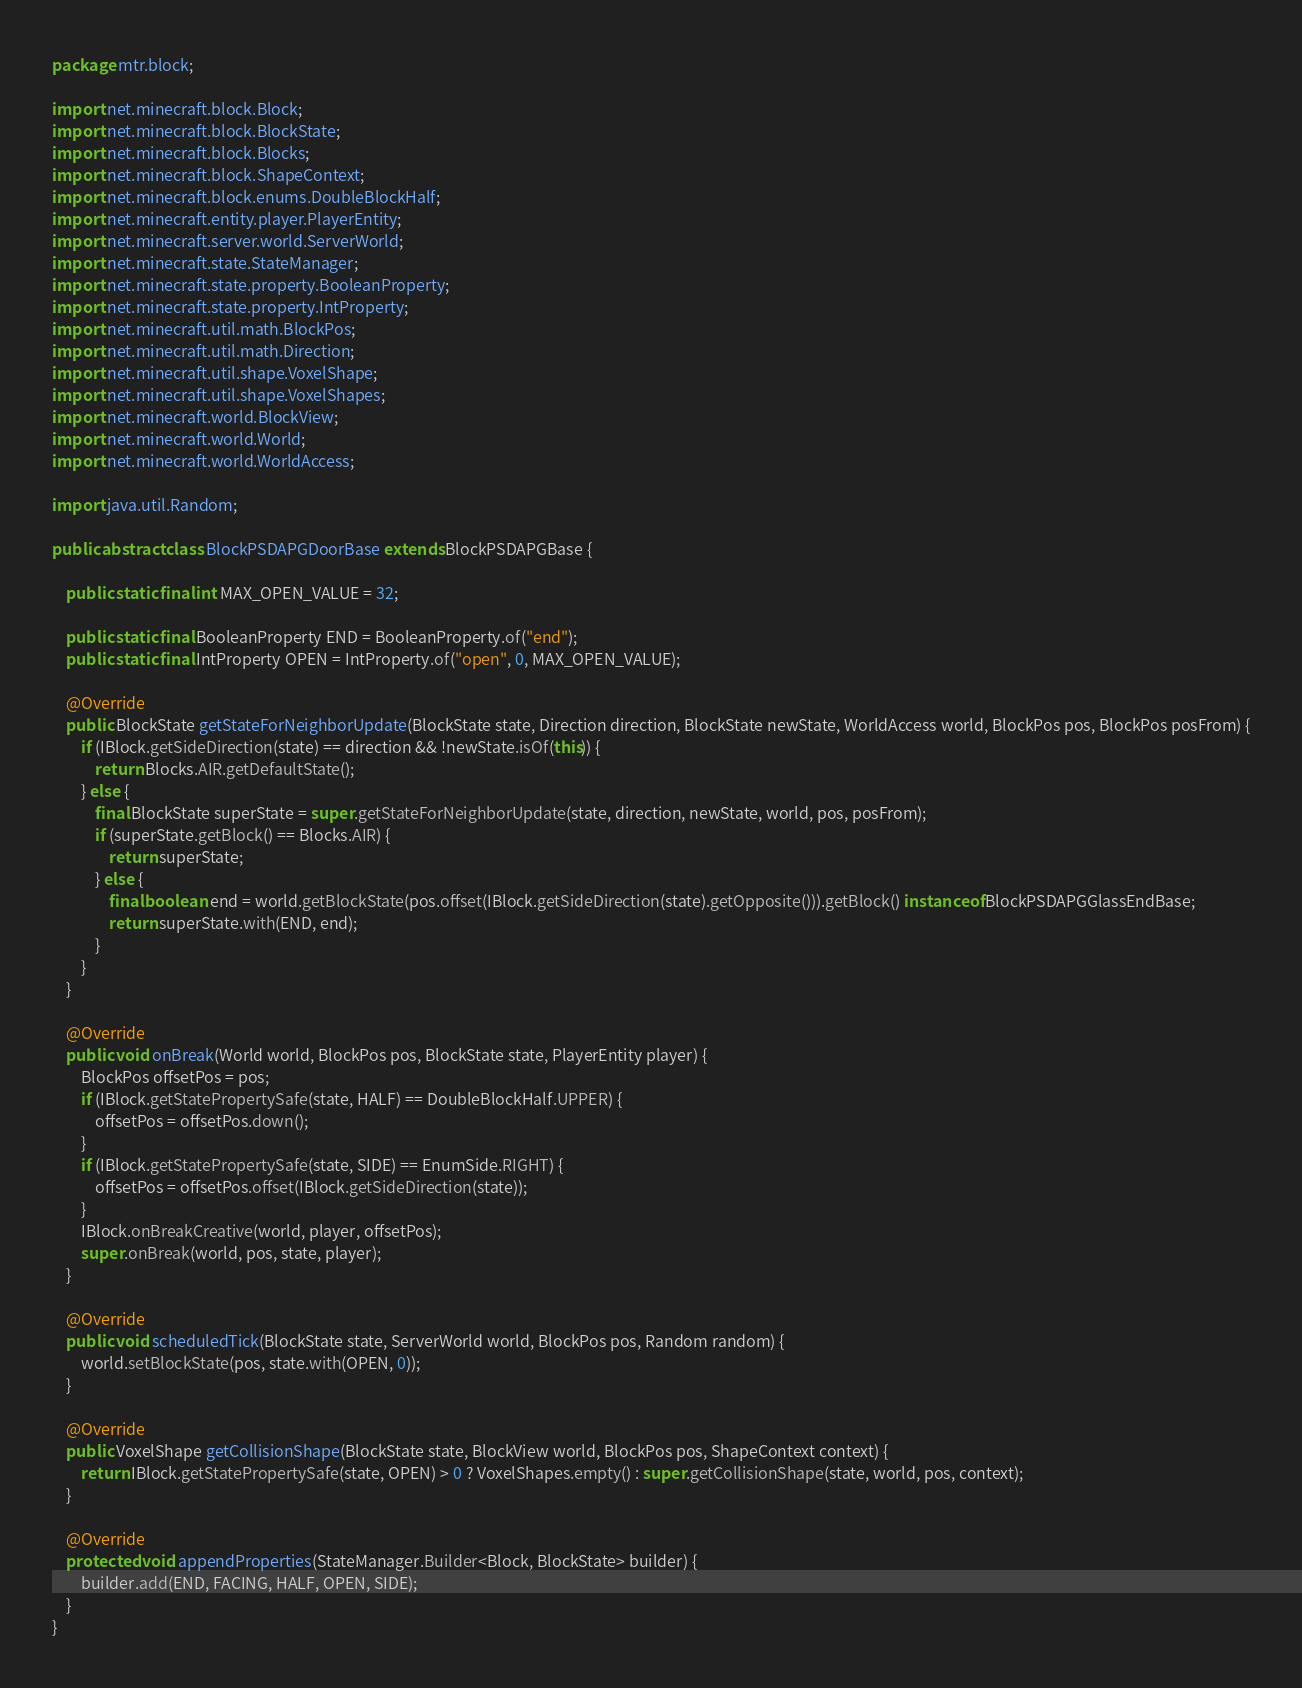<code> <loc_0><loc_0><loc_500><loc_500><_Java_>package mtr.block;

import net.minecraft.block.Block;
import net.minecraft.block.BlockState;
import net.minecraft.block.Blocks;
import net.minecraft.block.ShapeContext;
import net.minecraft.block.enums.DoubleBlockHalf;
import net.minecraft.entity.player.PlayerEntity;
import net.minecraft.server.world.ServerWorld;
import net.minecraft.state.StateManager;
import net.minecraft.state.property.BooleanProperty;
import net.minecraft.state.property.IntProperty;
import net.minecraft.util.math.BlockPos;
import net.minecraft.util.math.Direction;
import net.minecraft.util.shape.VoxelShape;
import net.minecraft.util.shape.VoxelShapes;
import net.minecraft.world.BlockView;
import net.minecraft.world.World;
import net.minecraft.world.WorldAccess;

import java.util.Random;

public abstract class BlockPSDAPGDoorBase extends BlockPSDAPGBase {

	public static final int MAX_OPEN_VALUE = 32;

	public static final BooleanProperty END = BooleanProperty.of("end");
	public static final IntProperty OPEN = IntProperty.of("open", 0, MAX_OPEN_VALUE);

	@Override
	public BlockState getStateForNeighborUpdate(BlockState state, Direction direction, BlockState newState, WorldAccess world, BlockPos pos, BlockPos posFrom) {
		if (IBlock.getSideDirection(state) == direction && !newState.isOf(this)) {
			return Blocks.AIR.getDefaultState();
		} else {
			final BlockState superState = super.getStateForNeighborUpdate(state, direction, newState, world, pos, posFrom);
			if (superState.getBlock() == Blocks.AIR) {
				return superState;
			} else {
				final boolean end = world.getBlockState(pos.offset(IBlock.getSideDirection(state).getOpposite())).getBlock() instanceof BlockPSDAPGGlassEndBase;
				return superState.with(END, end);
			}
		}
	}

	@Override
	public void onBreak(World world, BlockPos pos, BlockState state, PlayerEntity player) {
		BlockPos offsetPos = pos;
		if (IBlock.getStatePropertySafe(state, HALF) == DoubleBlockHalf.UPPER) {
			offsetPos = offsetPos.down();
		}
		if (IBlock.getStatePropertySafe(state, SIDE) == EnumSide.RIGHT) {
			offsetPos = offsetPos.offset(IBlock.getSideDirection(state));
		}
		IBlock.onBreakCreative(world, player, offsetPos);
		super.onBreak(world, pos, state, player);
	}

	@Override
	public void scheduledTick(BlockState state, ServerWorld world, BlockPos pos, Random random) {
		world.setBlockState(pos, state.with(OPEN, 0));
	}

	@Override
	public VoxelShape getCollisionShape(BlockState state, BlockView world, BlockPos pos, ShapeContext context) {
		return IBlock.getStatePropertySafe(state, OPEN) > 0 ? VoxelShapes.empty() : super.getCollisionShape(state, world, pos, context);
	}

	@Override
	protected void appendProperties(StateManager.Builder<Block, BlockState> builder) {
		builder.add(END, FACING, HALF, OPEN, SIDE);
	}
}
</code> 